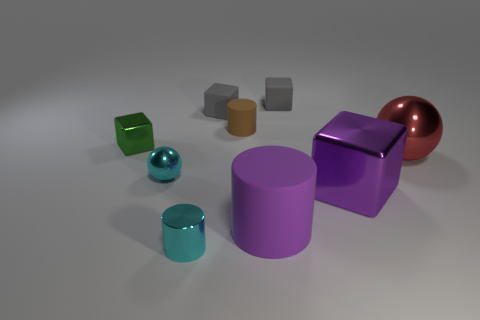Subtract all matte cylinders. How many cylinders are left? 1 Subtract 1 cylinders. How many cylinders are left? 2 Add 5 big matte cylinders. How many big matte cylinders are left? 6 Add 3 big purple cubes. How many big purple cubes exist? 4 Add 1 small spheres. How many objects exist? 10 Subtract all red spheres. How many spheres are left? 1 Subtract 0 green cylinders. How many objects are left? 9 Subtract all cylinders. How many objects are left? 6 Subtract all brown spheres. Subtract all brown blocks. How many spheres are left? 2 Subtract all red blocks. How many cyan cylinders are left? 1 